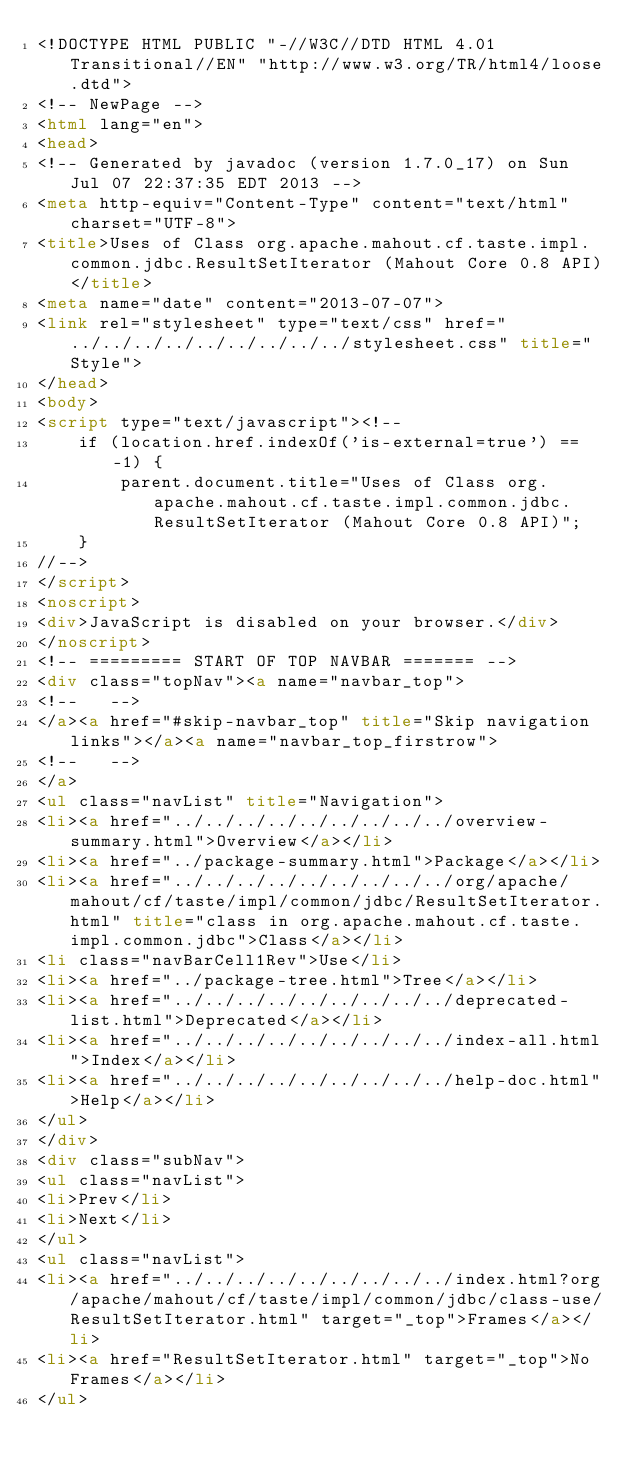Convert code to text. <code><loc_0><loc_0><loc_500><loc_500><_HTML_><!DOCTYPE HTML PUBLIC "-//W3C//DTD HTML 4.01 Transitional//EN" "http://www.w3.org/TR/html4/loose.dtd">
<!-- NewPage -->
<html lang="en">
<head>
<!-- Generated by javadoc (version 1.7.0_17) on Sun Jul 07 22:37:35 EDT 2013 -->
<meta http-equiv="Content-Type" content="text/html" charset="UTF-8">
<title>Uses of Class org.apache.mahout.cf.taste.impl.common.jdbc.ResultSetIterator (Mahout Core 0.8 API)</title>
<meta name="date" content="2013-07-07">
<link rel="stylesheet" type="text/css" href="../../../../../../../../../stylesheet.css" title="Style">
</head>
<body>
<script type="text/javascript"><!--
    if (location.href.indexOf('is-external=true') == -1) {
        parent.document.title="Uses of Class org.apache.mahout.cf.taste.impl.common.jdbc.ResultSetIterator (Mahout Core 0.8 API)";
    }
//-->
</script>
<noscript>
<div>JavaScript is disabled on your browser.</div>
</noscript>
<!-- ========= START OF TOP NAVBAR ======= -->
<div class="topNav"><a name="navbar_top">
<!--   -->
</a><a href="#skip-navbar_top" title="Skip navigation links"></a><a name="navbar_top_firstrow">
<!--   -->
</a>
<ul class="navList" title="Navigation">
<li><a href="../../../../../../../../../overview-summary.html">Overview</a></li>
<li><a href="../package-summary.html">Package</a></li>
<li><a href="../../../../../../../../../org/apache/mahout/cf/taste/impl/common/jdbc/ResultSetIterator.html" title="class in org.apache.mahout.cf.taste.impl.common.jdbc">Class</a></li>
<li class="navBarCell1Rev">Use</li>
<li><a href="../package-tree.html">Tree</a></li>
<li><a href="../../../../../../../../../deprecated-list.html">Deprecated</a></li>
<li><a href="../../../../../../../../../index-all.html">Index</a></li>
<li><a href="../../../../../../../../../help-doc.html">Help</a></li>
</ul>
</div>
<div class="subNav">
<ul class="navList">
<li>Prev</li>
<li>Next</li>
</ul>
<ul class="navList">
<li><a href="../../../../../../../../../index.html?org/apache/mahout/cf/taste/impl/common/jdbc/class-use/ResultSetIterator.html" target="_top">Frames</a></li>
<li><a href="ResultSetIterator.html" target="_top">No Frames</a></li>
</ul></code> 